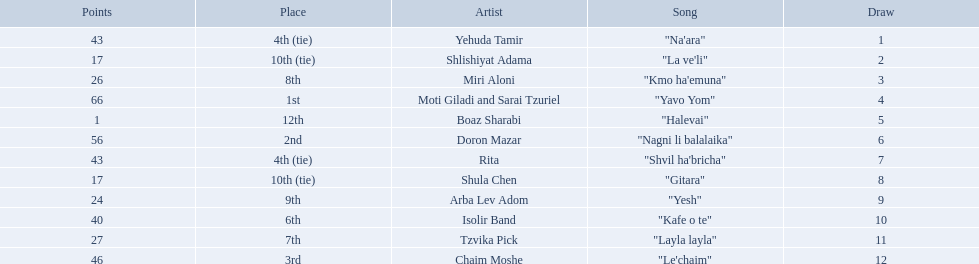What is the place of the contestant who received only 1 point? 12th. What is the name of the artist listed in the previous question? Boaz Sharabi. 